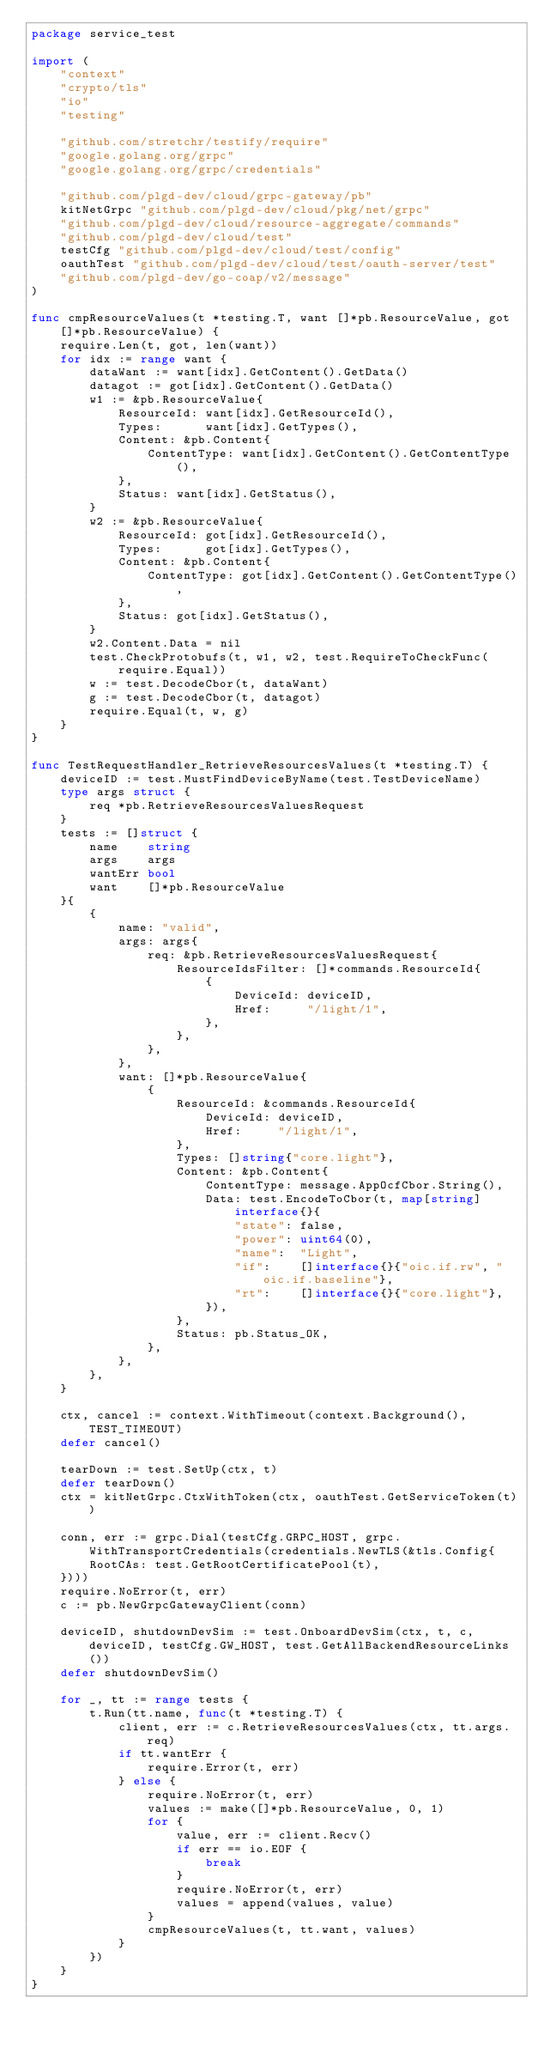Convert code to text. <code><loc_0><loc_0><loc_500><loc_500><_Go_>package service_test

import (
	"context"
	"crypto/tls"
	"io"
	"testing"

	"github.com/stretchr/testify/require"
	"google.golang.org/grpc"
	"google.golang.org/grpc/credentials"

	"github.com/plgd-dev/cloud/grpc-gateway/pb"
	kitNetGrpc "github.com/plgd-dev/cloud/pkg/net/grpc"
	"github.com/plgd-dev/cloud/resource-aggregate/commands"
	"github.com/plgd-dev/cloud/test"
	testCfg "github.com/plgd-dev/cloud/test/config"
	oauthTest "github.com/plgd-dev/cloud/test/oauth-server/test"
	"github.com/plgd-dev/go-coap/v2/message"
)

func cmpResourceValues(t *testing.T, want []*pb.ResourceValue, got []*pb.ResourceValue) {
	require.Len(t, got, len(want))
	for idx := range want {
		dataWant := want[idx].GetContent().GetData()
		datagot := got[idx].GetContent().GetData()
		w1 := &pb.ResourceValue{
			ResourceId: want[idx].GetResourceId(),
			Types:      want[idx].GetTypes(),
			Content: &pb.Content{
				ContentType: want[idx].GetContent().GetContentType(),
			},
			Status: want[idx].GetStatus(),
		}
		w2 := &pb.ResourceValue{
			ResourceId: got[idx].GetResourceId(),
			Types:      got[idx].GetTypes(),
			Content: &pb.Content{
				ContentType: got[idx].GetContent().GetContentType(),
			},
			Status: got[idx].GetStatus(),
		}
		w2.Content.Data = nil
		test.CheckProtobufs(t, w1, w2, test.RequireToCheckFunc(require.Equal))
		w := test.DecodeCbor(t, dataWant)
		g := test.DecodeCbor(t, datagot)
		require.Equal(t, w, g)
	}
}

func TestRequestHandler_RetrieveResourcesValues(t *testing.T) {
	deviceID := test.MustFindDeviceByName(test.TestDeviceName)
	type args struct {
		req *pb.RetrieveResourcesValuesRequest
	}
	tests := []struct {
		name    string
		args    args
		wantErr bool
		want    []*pb.ResourceValue
	}{
		{
			name: "valid",
			args: args{
				req: &pb.RetrieveResourcesValuesRequest{
					ResourceIdsFilter: []*commands.ResourceId{
						{
							DeviceId: deviceID,
							Href:     "/light/1",
						},
					},
				},
			},
			want: []*pb.ResourceValue{
				{
					ResourceId: &commands.ResourceId{
						DeviceId: deviceID,
						Href:     "/light/1",
					},
					Types: []string{"core.light"},
					Content: &pb.Content{
						ContentType: message.AppOcfCbor.String(),
						Data: test.EncodeToCbor(t, map[string]interface{}{
							"state": false,
							"power": uint64(0),
							"name":  "Light",
							"if":    []interface{}{"oic.if.rw", "oic.if.baseline"},
							"rt":    []interface{}{"core.light"},
						}),
					},
					Status: pb.Status_OK,
				},
			},
		},
	}

	ctx, cancel := context.WithTimeout(context.Background(), TEST_TIMEOUT)
	defer cancel()

	tearDown := test.SetUp(ctx, t)
	defer tearDown()
	ctx = kitNetGrpc.CtxWithToken(ctx, oauthTest.GetServiceToken(t))

	conn, err := grpc.Dial(testCfg.GRPC_HOST, grpc.WithTransportCredentials(credentials.NewTLS(&tls.Config{
		RootCAs: test.GetRootCertificatePool(t),
	})))
	require.NoError(t, err)
	c := pb.NewGrpcGatewayClient(conn)

	deviceID, shutdownDevSim := test.OnboardDevSim(ctx, t, c, deviceID, testCfg.GW_HOST, test.GetAllBackendResourceLinks())
	defer shutdownDevSim()

	for _, tt := range tests {
		t.Run(tt.name, func(t *testing.T) {
			client, err := c.RetrieveResourcesValues(ctx, tt.args.req)
			if tt.wantErr {
				require.Error(t, err)
			} else {
				require.NoError(t, err)
				values := make([]*pb.ResourceValue, 0, 1)
				for {
					value, err := client.Recv()
					if err == io.EOF {
						break
					}
					require.NoError(t, err)
					values = append(values, value)
				}
				cmpResourceValues(t, tt.want, values)
			}
		})
	}
}
</code> 